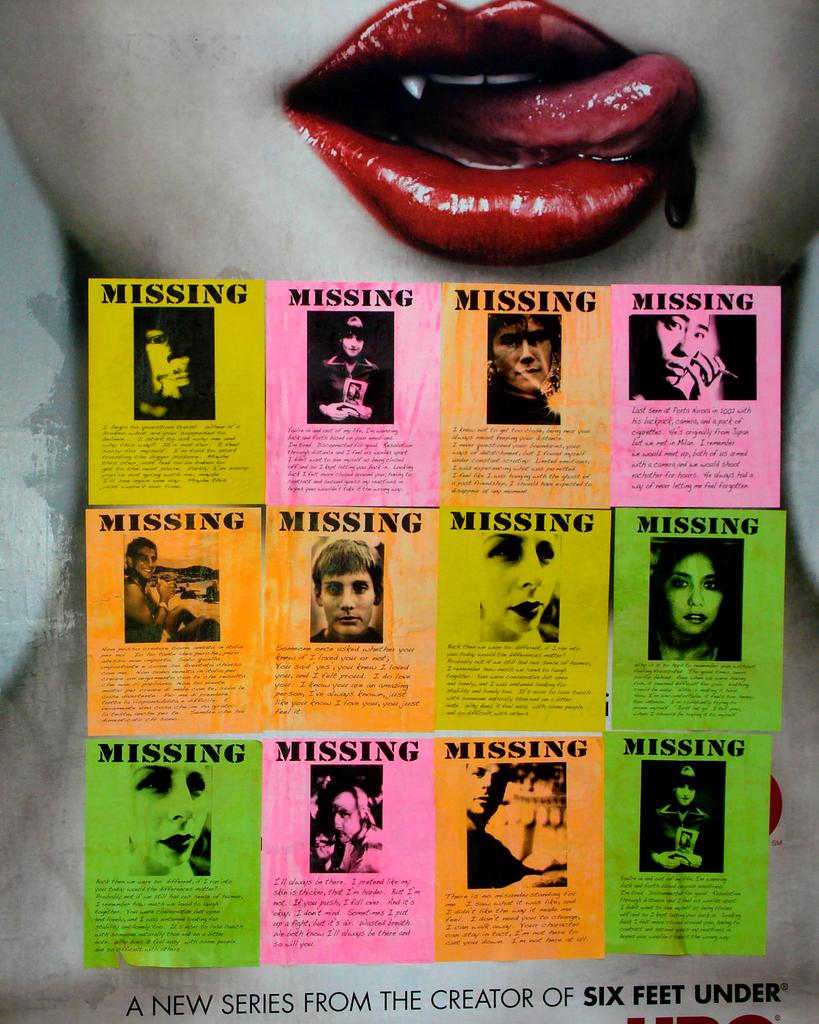What is present on the poster in the image? The poster contains images and text. Can you describe the text on the poster? There is text at the bottom of the poster. What else can be seen in the image besides the poster? There is a girl in the background of the image. What type of trees can be seen growing on the poster? There are no trees depicted on the poster; it contains images and text related to other subjects. 